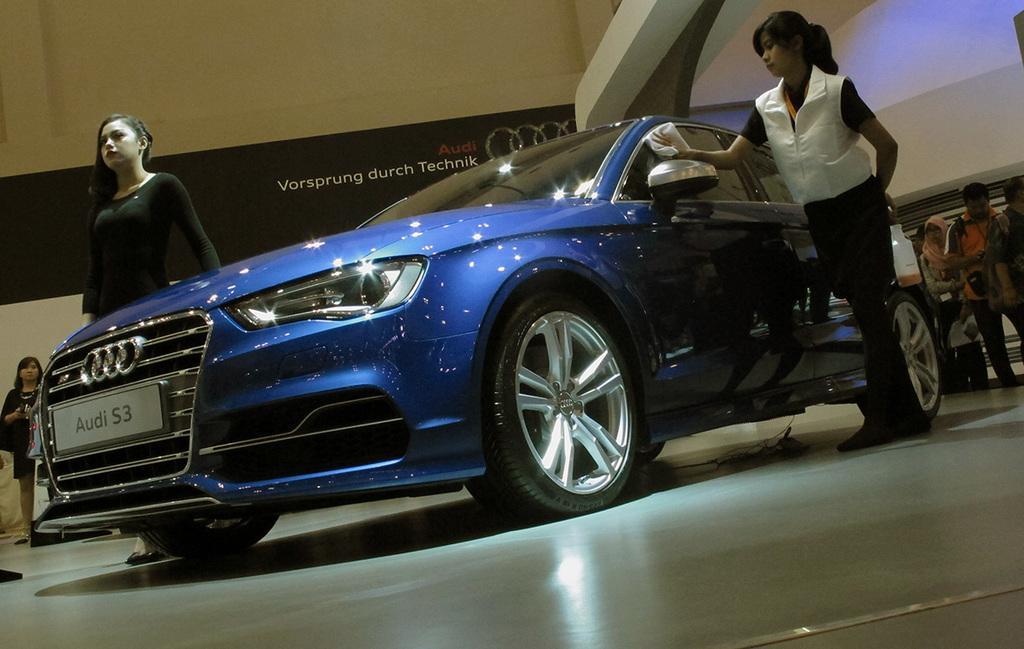Can you describe this image briefly? In this image in the center there is a car which is blue in colour and there are women standing beside the car. In the background there is a banner with some text written on it which is black in colour and there are persons standing and there is a wall. 